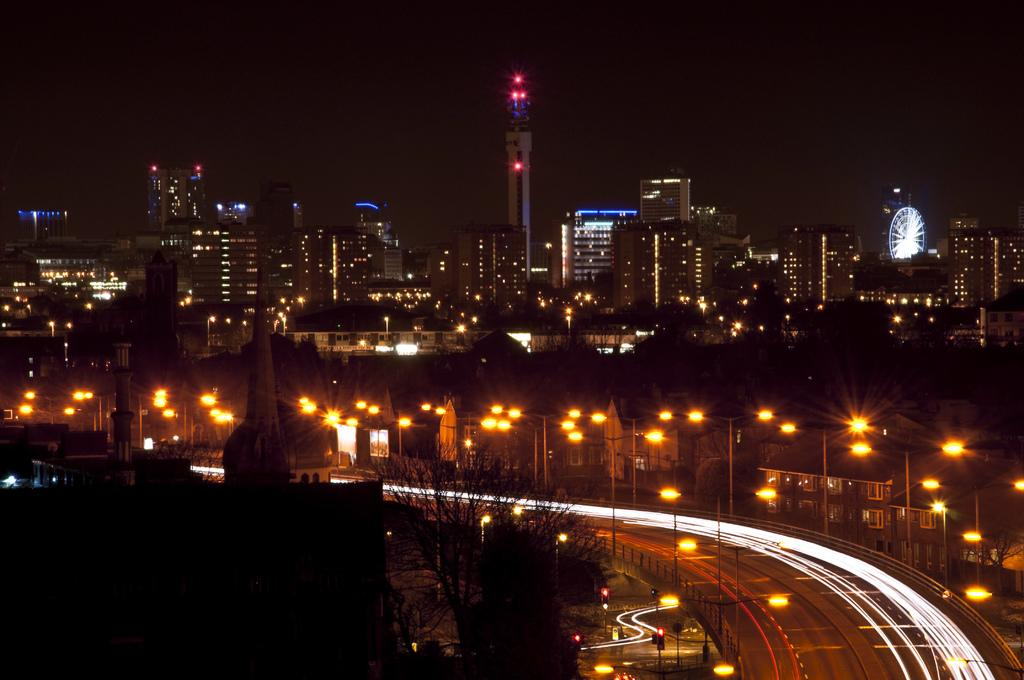What is the main feature of the image? There is a road in the image. What infrastructure elements can be seen alongside the road? Electric poles with lights and traffic signals are present in the image. What type of structures are visible in the image? There are buildings in the image. What natural elements are present in the image? Trees are present in the image. How would you describe the lighting conditions in the image? The background of the image appears to be dark. What flavor of pail can be seen in the image? There is no pail present in the image, and therefore no flavor can be determined. 